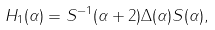<formula> <loc_0><loc_0><loc_500><loc_500>H _ { 1 } ( \alpha ) = S ^ { - 1 } ( \alpha + 2 ) \Delta ( \alpha ) S ( \alpha ) ,</formula> 